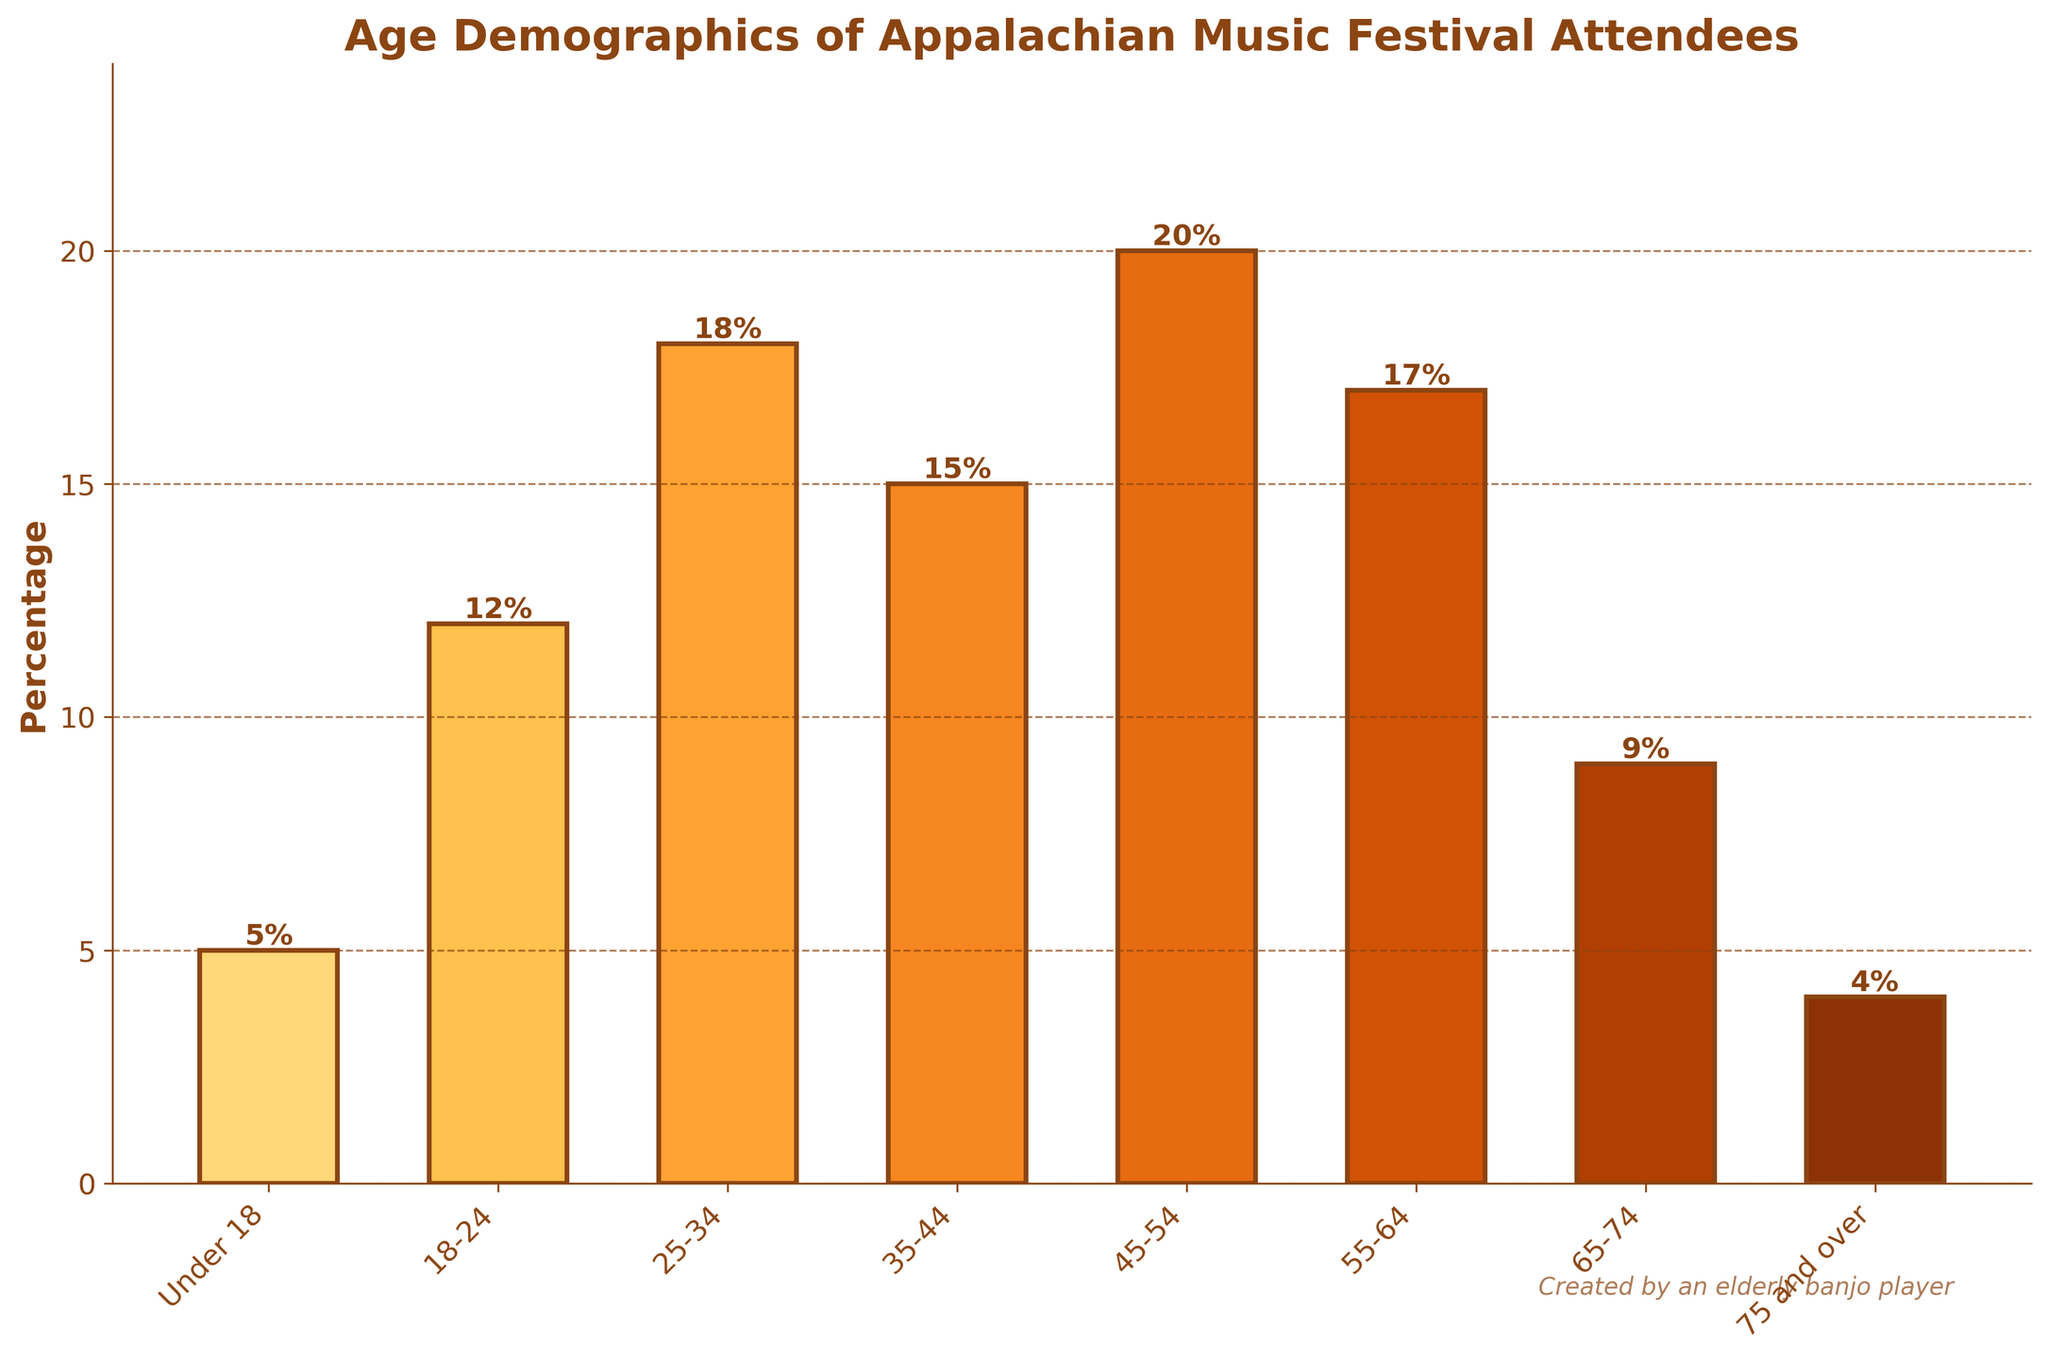Which age group has the highest percentage of attendees? The tallest bar represents the highest percentage of attendees. The bar for the 45-54 age group is the tallest.
Answer: 45-54 Which age group has the lowest percentage of attendees? The shortest bar represents the lowest percentage of attendees. The bar for the 75 and over age group is the shortest.
Answer: 75 and over What's the sum of the percentages for the age groups 18-24 and 25-34? The percentages for 18-24 and 25-34 are 12% and 18%, respectively. Adding them together gives 12 + 18 = 30.
Answer: 30% What's the difference in percentage between the 55-64 and 65-74 age groups? The percentages for 55-64 and 65-74 are 17% and 9%, respectively. Subtracting them gives 17 - 9 = 8.
Answer: 8% What is the average percentage of the three oldest age groups (55-64, 65-74, 75 and over)? The percentages for 55-64, 65-74, and 75 and over are 17%, 9%, and 4% respectively. Summing them gives 17 + 9 + 4 = 30. Dividing by 3 gives the average: 30 / 3 = 10.
Answer: 10% Is the percentage of attendees under 18 greater than the percentage of attendees 75 and over? The percentage for under 18 is 5% and for 75 and over is 4%. Comparing them shows that 5% is greater than 4%.
Answer: Yes Which age group has a taller bar: 35-44 or 25-34? The percentage for 35-44 is 15% and for 25-34 is 18%. The bar for 25-34 is taller.
Answer: 25-34 What's the combined percentage of attendees aged between 18 and 34 inclusive? The percentages for 18-24 and 25-34 are 12% and 18% respectively. Adding them together gives 12 + 18 = 30.
Answer: 30% Which is greater: the percentage of attendees aged 45-64 or the percentage of attendees aged 65 and over? The percentages for 45-64 are 20% + 17% = 37%. The percentages for 65 and over are 9% + 4% = 13%. 37% is greater than 13%.
Answer: 45-64 How many age groups have a percentage of 15% or higher? The age groups with percentages 15% or higher are 25-34 (18%), 35-44 (15%), 45-54 (20%), and 55-64 (17%). There are 4 such groups.
Answer: 4 